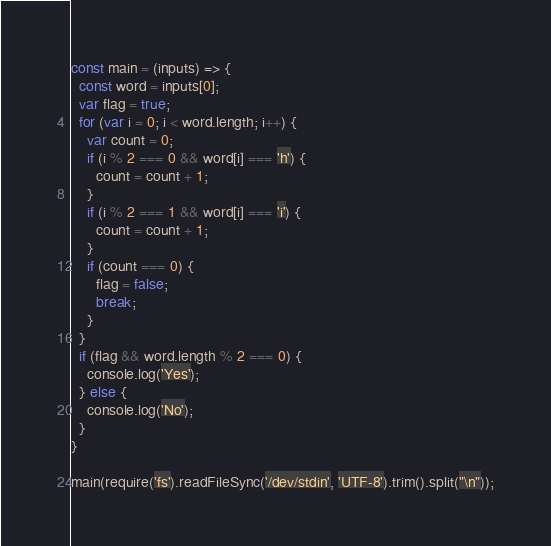<code> <loc_0><loc_0><loc_500><loc_500><_JavaScript_>const main = (inputs) => {
  const word = inputs[0];
  var flag = true;
  for (var i = 0; i < word.length; i++) {
    var count = 0;
    if (i % 2 === 0 && word[i] === 'h') {
      count = count + 1;
    }
    if (i % 2 === 1 && word[i] === 'i') {
      count = count + 1;
    }
    if (count === 0) {
      flag = false;
      break;
    }
  }
  if (flag && word.length % 2 === 0) {
    console.log('Yes');
  } else {
    console.log('No');
  }
}

main(require('fs').readFileSync('/dev/stdin', 'UTF-8').trim().split("\n"));</code> 